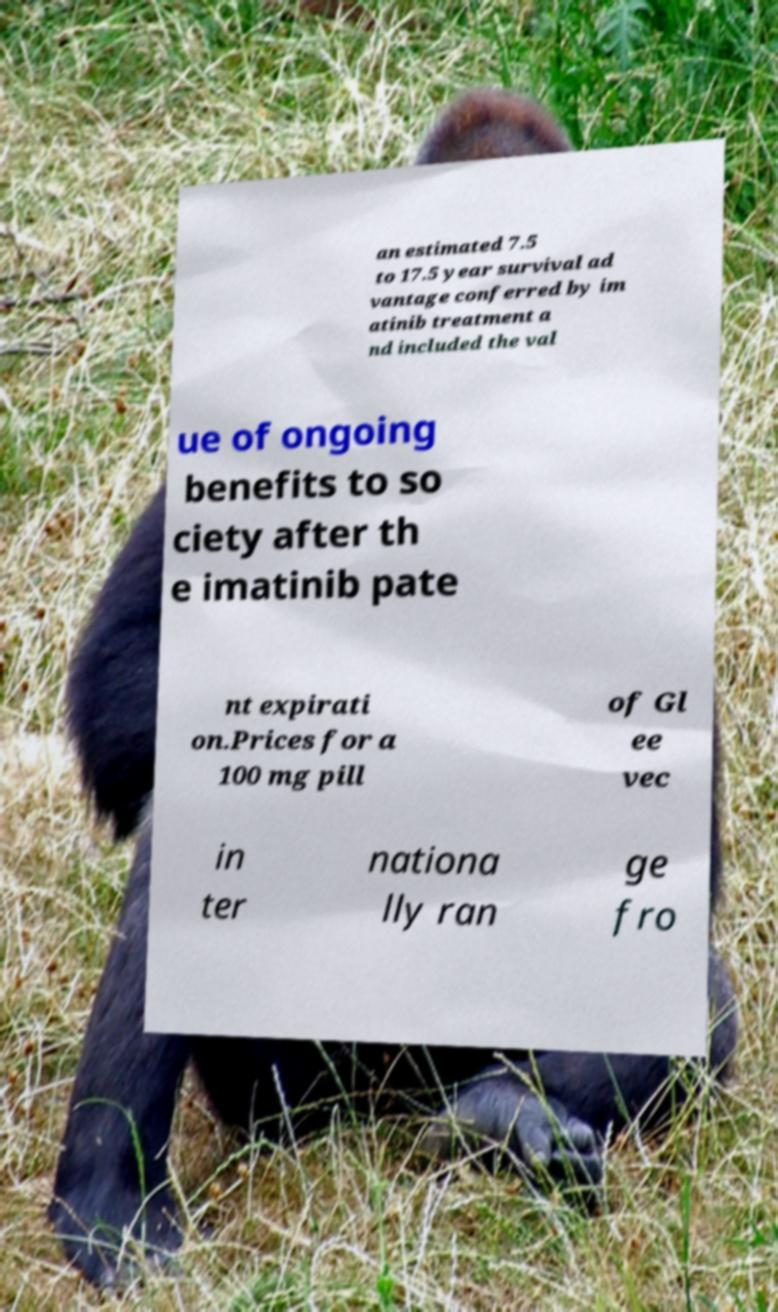Could you extract and type out the text from this image? an estimated 7.5 to 17.5 year survival ad vantage conferred by im atinib treatment a nd included the val ue of ongoing benefits to so ciety after th e imatinib pate nt expirati on.Prices for a 100 mg pill of Gl ee vec in ter nationa lly ran ge fro 